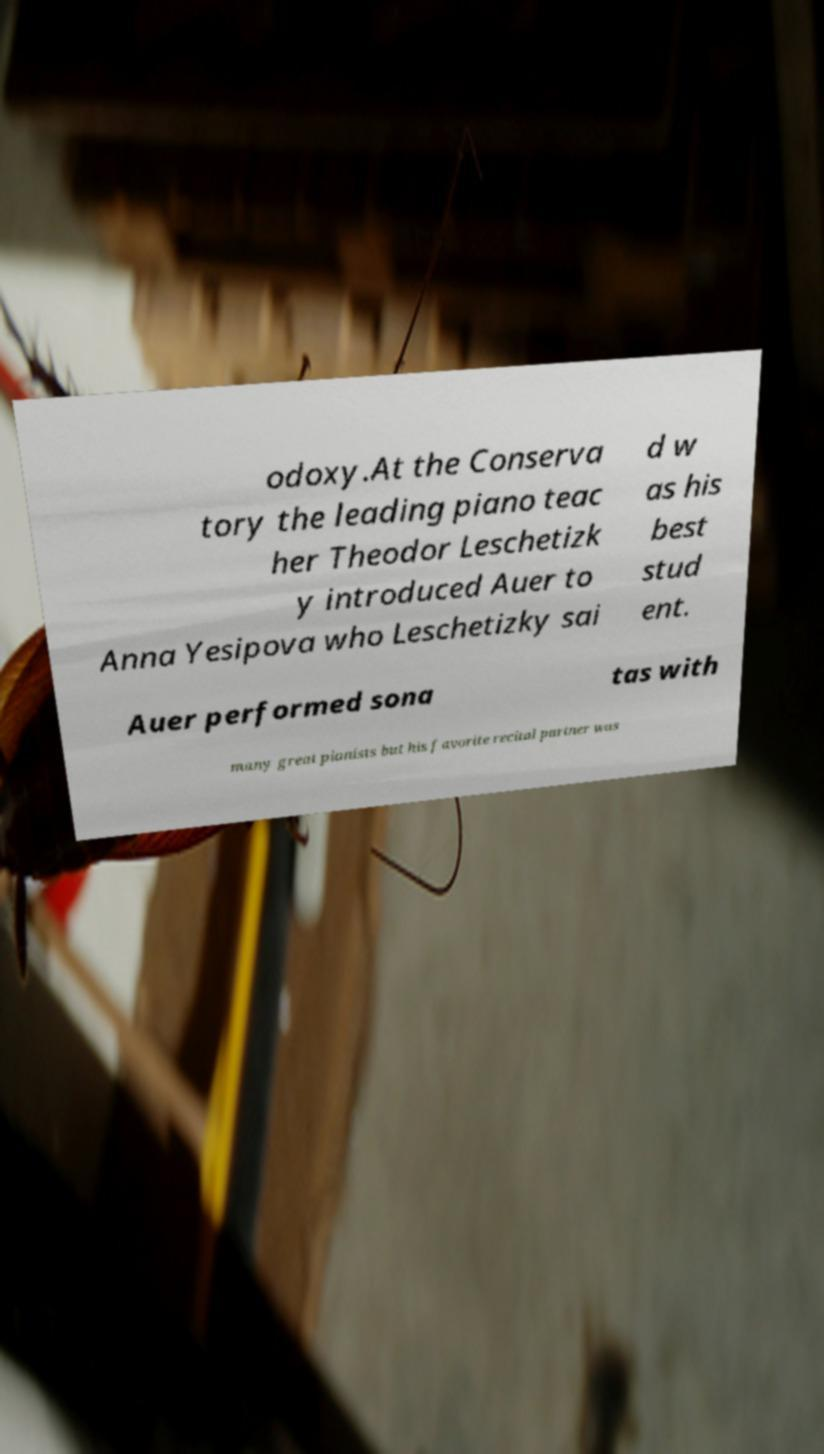For documentation purposes, I need the text within this image transcribed. Could you provide that? odoxy.At the Conserva tory the leading piano teac her Theodor Leschetizk y introduced Auer to Anna Yesipova who Leschetizky sai d w as his best stud ent. Auer performed sona tas with many great pianists but his favorite recital partner was 